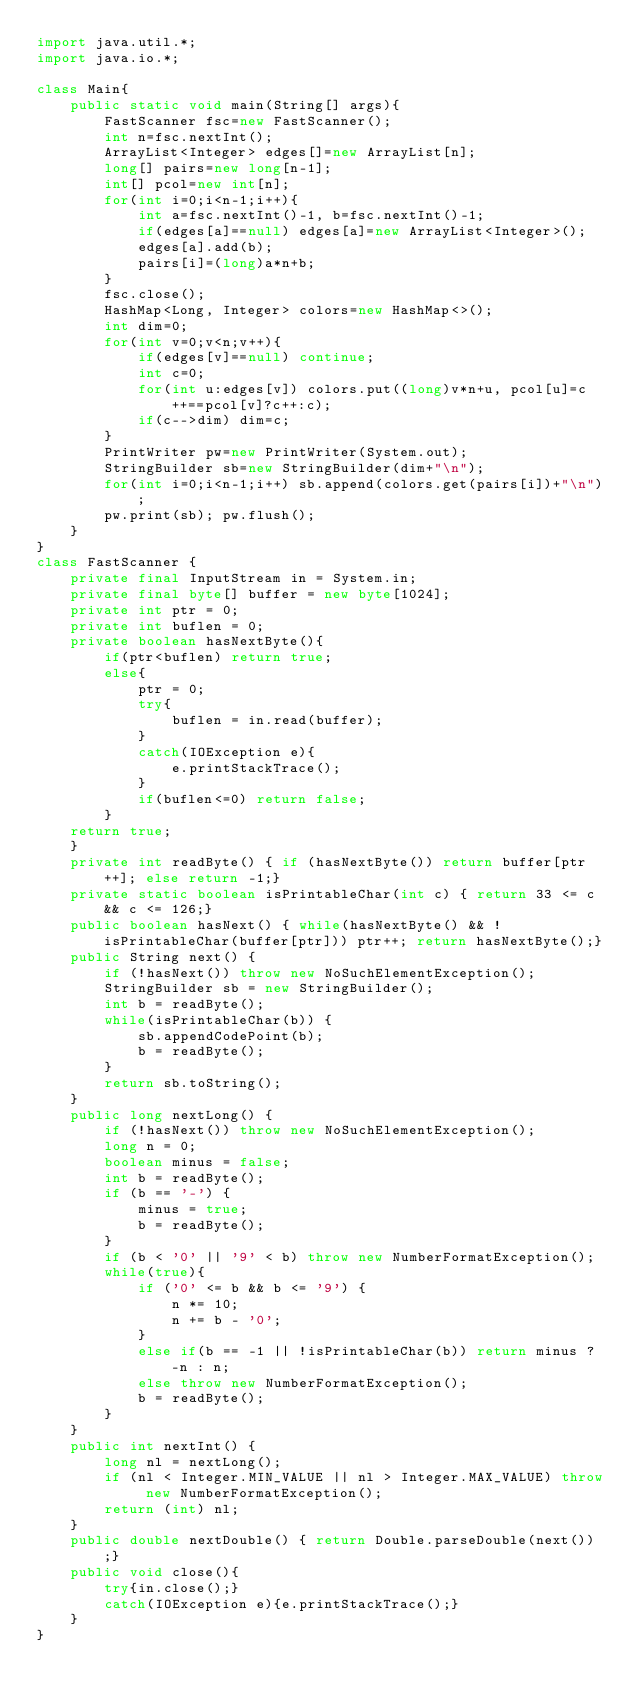Convert code to text. <code><loc_0><loc_0><loc_500><loc_500><_Java_>import java.util.*;
import java.io.*;

class Main{
    public static void main(String[] args){
        FastScanner fsc=new FastScanner();
        int n=fsc.nextInt();
        ArrayList<Integer> edges[]=new ArrayList[n];
        long[] pairs=new long[n-1];
        int[] pcol=new int[n];
        for(int i=0;i<n-1;i++){
            int a=fsc.nextInt()-1, b=fsc.nextInt()-1;
            if(edges[a]==null) edges[a]=new ArrayList<Integer>();
            edges[a].add(b);
            pairs[i]=(long)a*n+b;
        }
        fsc.close();
        HashMap<Long, Integer> colors=new HashMap<>();
        int dim=0;
        for(int v=0;v<n;v++){
            if(edges[v]==null) continue;
            int c=0;
            for(int u:edges[v]) colors.put((long)v*n+u, pcol[u]=c++==pcol[v]?c++:c);
            if(c-->dim) dim=c;
        }
        PrintWriter pw=new PrintWriter(System.out);
        StringBuilder sb=new StringBuilder(dim+"\n");
        for(int i=0;i<n-1;i++) sb.append(colors.get(pairs[i])+"\n");
        pw.print(sb); pw.flush();
    }
}
class FastScanner {
    private final InputStream in = System.in;
    private final byte[] buffer = new byte[1024];
    private int ptr = 0;
    private int buflen = 0;
    private boolean hasNextByte(){
        if(ptr<buflen) return true;
        else{
            ptr = 0;
            try{
                buflen = in.read(buffer);
            }
            catch(IOException e){
                e.printStackTrace();
            }
            if(buflen<=0) return false;
        }
    return true;
    }
    private int readByte() { if (hasNextByte()) return buffer[ptr++]; else return -1;}
    private static boolean isPrintableChar(int c) { return 33 <= c && c <= 126;}
    public boolean hasNext() { while(hasNextByte() && !isPrintableChar(buffer[ptr])) ptr++; return hasNextByte();}
    public String next() {
        if (!hasNext()) throw new NoSuchElementException();
        StringBuilder sb = new StringBuilder();
        int b = readByte();
        while(isPrintableChar(b)) {
            sb.appendCodePoint(b);
            b = readByte();
        }
        return sb.toString();
    }
    public long nextLong() {
        if (!hasNext()) throw new NoSuchElementException();
        long n = 0;
        boolean minus = false;
        int b = readByte();
        if (b == '-') {
            minus = true;
            b = readByte();
        }
        if (b < '0' || '9' < b) throw new NumberFormatException();
        while(true){
            if ('0' <= b && b <= '9') {
                n *= 10;
                n += b - '0';
            }
            else if(b == -1 || !isPrintableChar(b)) return minus ? -n : n;
            else throw new NumberFormatException();
            b = readByte();
        }
    }
    public int nextInt() {
        long nl = nextLong();
        if (nl < Integer.MIN_VALUE || nl > Integer.MAX_VALUE) throw new NumberFormatException();
        return (int) nl;
    }
    public double nextDouble() { return Double.parseDouble(next());}
    public void close(){
        try{in.close();}
        catch(IOException e){e.printStackTrace();}
    }
}</code> 